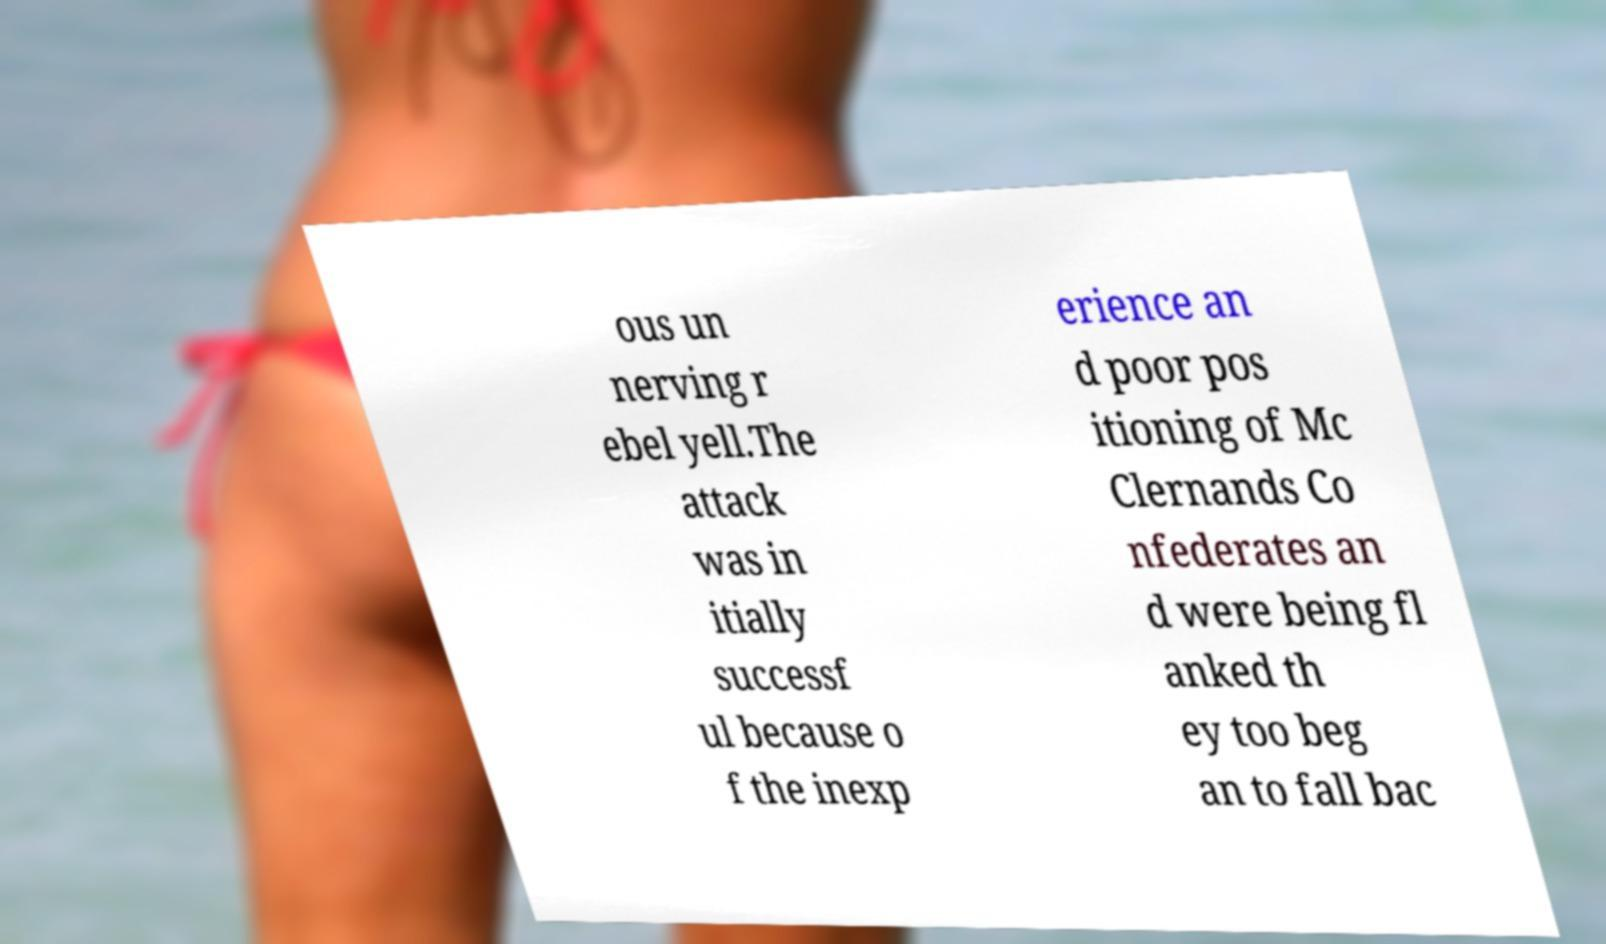Can you read and provide the text displayed in the image?This photo seems to have some interesting text. Can you extract and type it out for me? ous un nerving r ebel yell.The attack was in itially successf ul because o f the inexp erience an d poor pos itioning of Mc Clernands Co nfederates an d were being fl anked th ey too beg an to fall bac 